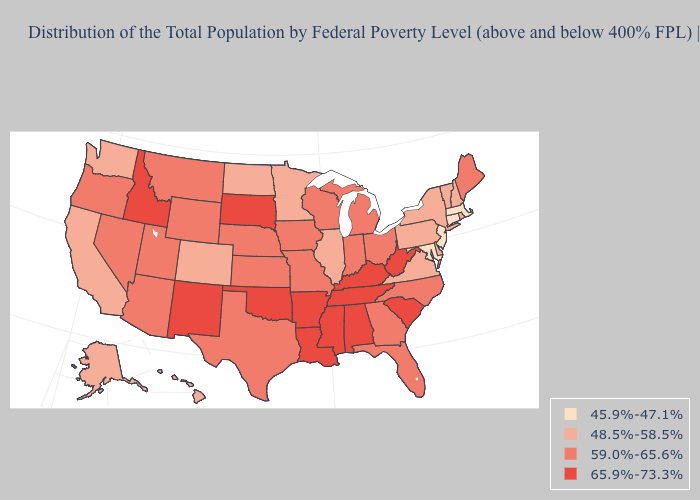Does New Mexico have the highest value in the USA?
Answer briefly. Yes. What is the value of Maine?
Quick response, please. 59.0%-65.6%. What is the lowest value in states that border Georgia?
Quick response, please. 59.0%-65.6%. Name the states that have a value in the range 48.5%-58.5%?
Be succinct. Alaska, California, Colorado, Delaware, Hawaii, Illinois, Minnesota, New Hampshire, New York, North Dakota, Pennsylvania, Rhode Island, Vermont, Virginia, Washington. Name the states that have a value in the range 45.9%-47.1%?
Concise answer only. Connecticut, Maryland, Massachusetts, New Jersey. Among the states that border Connecticut , does New York have the lowest value?
Write a very short answer. No. Among the states that border Louisiana , which have the highest value?
Keep it brief. Arkansas, Mississippi. Does Georgia have the highest value in the USA?
Be succinct. No. Name the states that have a value in the range 45.9%-47.1%?
Give a very brief answer. Connecticut, Maryland, Massachusetts, New Jersey. What is the highest value in states that border Alabama?
Short answer required. 65.9%-73.3%. What is the highest value in states that border Maryland?
Concise answer only. 65.9%-73.3%. Does the map have missing data?
Short answer required. No. What is the value of Nebraska?
Give a very brief answer. 59.0%-65.6%. What is the lowest value in the South?
Keep it brief. 45.9%-47.1%. Which states have the lowest value in the USA?
Be succinct. Connecticut, Maryland, Massachusetts, New Jersey. 